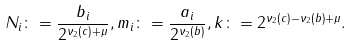<formula> <loc_0><loc_0><loc_500><loc_500>N _ { i } \colon = \frac { b _ { i } } { 2 ^ { \nu _ { 2 } ( c ) + \mu } } , m _ { i } \colon = \frac { a _ { i } } { 2 ^ { \nu _ { 2 } ( b ) } } , k \colon = 2 ^ { \nu _ { 2 } ( c ) - \nu _ { 2 } ( b ) + \mu } .</formula> 